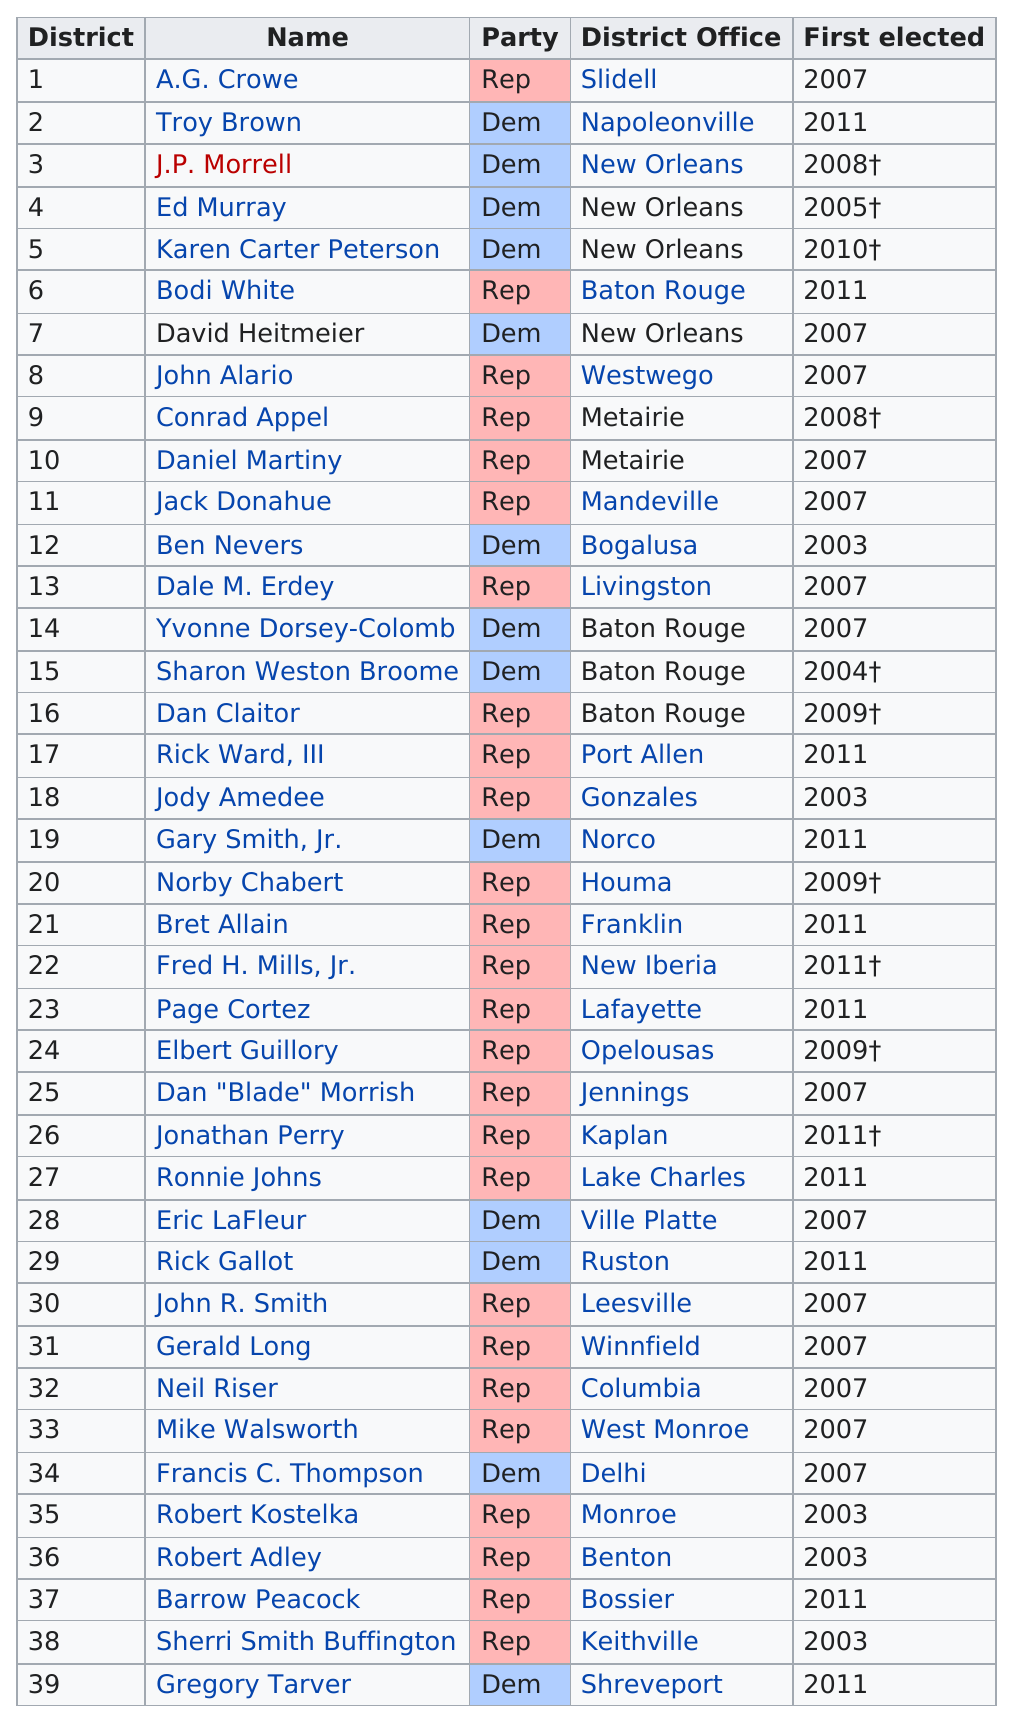List a handful of essential elements in this visual. There are 13 Democrats currently holding office. There are 39 total senators. Amedee was elected earlier than Cortez. Four senators are from Baton Rouge. John P. Morrell was elected to the Louisiana State Senate in 2008, the same year as Senator Conrad Appel. 